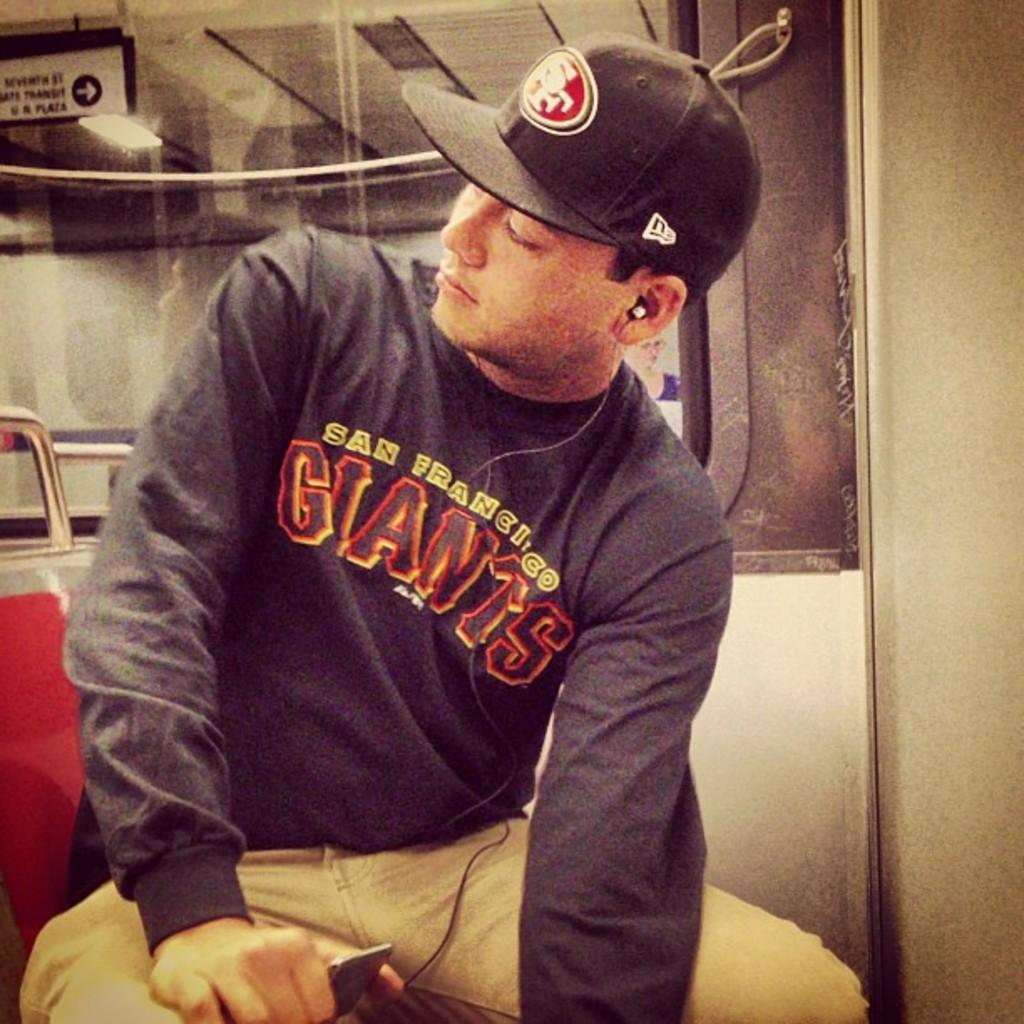<image>
Relay a brief, clear account of the picture shown. Man sitting with a San Francisco Giants shirt on. 